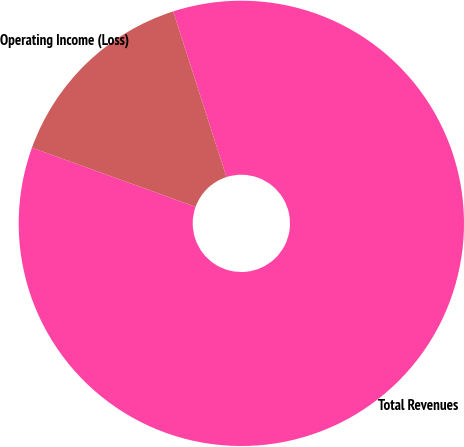Convert chart to OTSL. <chart><loc_0><loc_0><loc_500><loc_500><pie_chart><fcel>Total Revenues<fcel>Operating Income (Loss)<nl><fcel>85.47%<fcel>14.53%<nl></chart> 